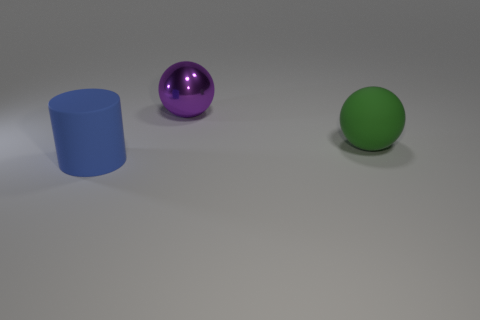Add 1 purple metallic things. How many objects exist? 4 Subtract all cylinders. How many objects are left? 2 Add 2 red things. How many red things exist? 2 Subtract 0 brown blocks. How many objects are left? 3 Subtract all blue matte cylinders. Subtract all big cylinders. How many objects are left? 1 Add 1 purple things. How many purple things are left? 2 